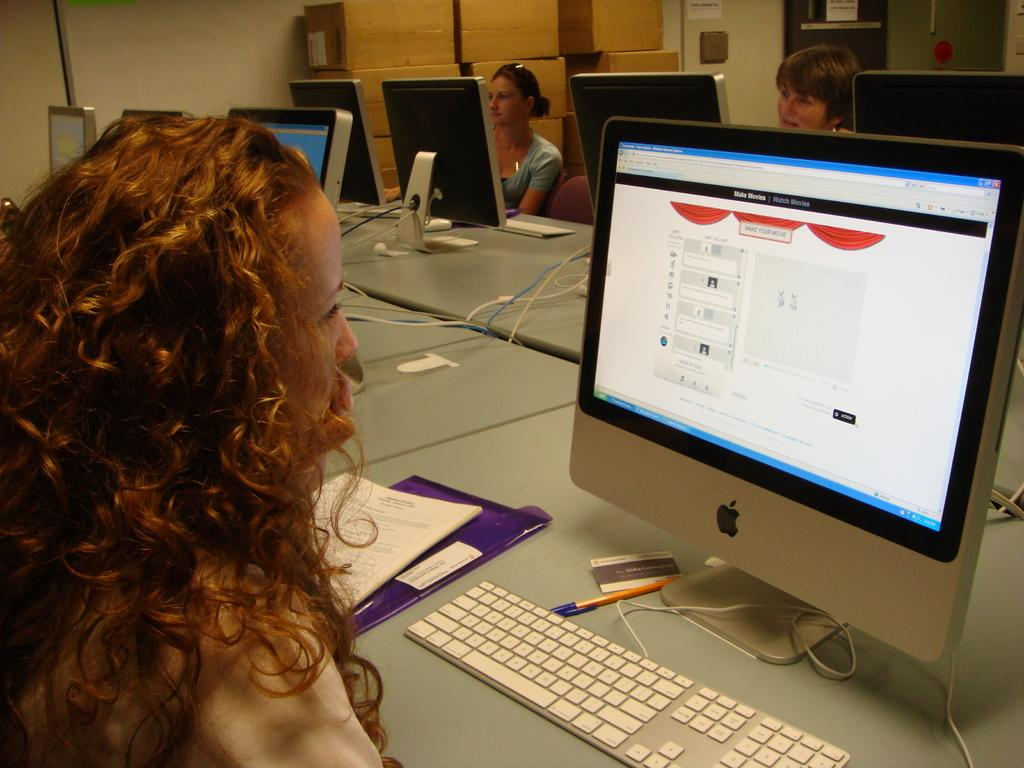Who is the main subject in the foreground of the image? There is a lady in the foreground of the image. What is the lady doing in the image? The lady is looking at a monitor. How many ladies are present in the image? There are two ladies in the image. What are the two ladies doing in the image? The two ladies are operating computers. What type of tramp can be seen jumping in the background of the image? There is no tramp present in the image; it features two ladies operating computers. How many bells are attached to the van in the image? There is no van or bells present in the image. 